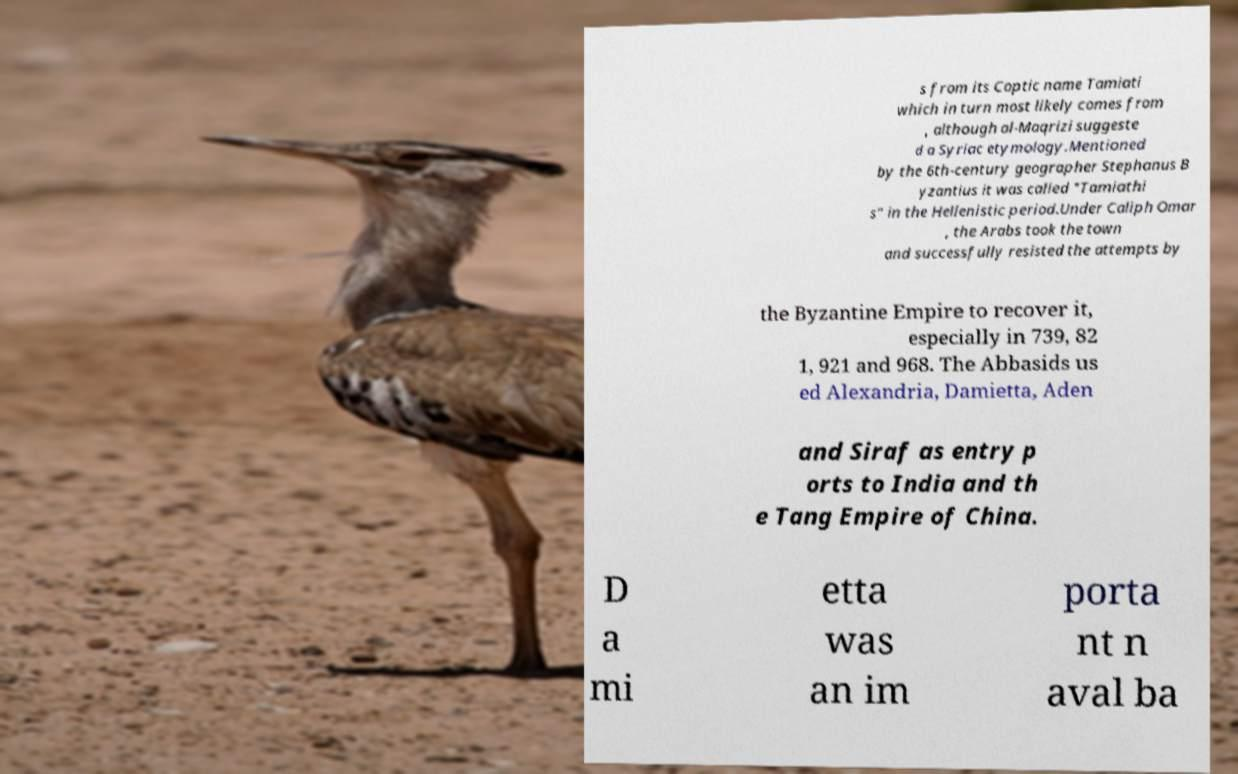For documentation purposes, I need the text within this image transcribed. Could you provide that? s from its Coptic name Tamiati which in turn most likely comes from , although al-Maqrizi suggeste d a Syriac etymology.Mentioned by the 6th-century geographer Stephanus B yzantius it was called "Tamiathi s" in the Hellenistic period.Under Caliph Omar , the Arabs took the town and successfully resisted the attempts by the Byzantine Empire to recover it, especially in 739, 82 1, 921 and 968. The Abbasids us ed Alexandria, Damietta, Aden and Siraf as entry p orts to India and th e Tang Empire of China. D a mi etta was an im porta nt n aval ba 